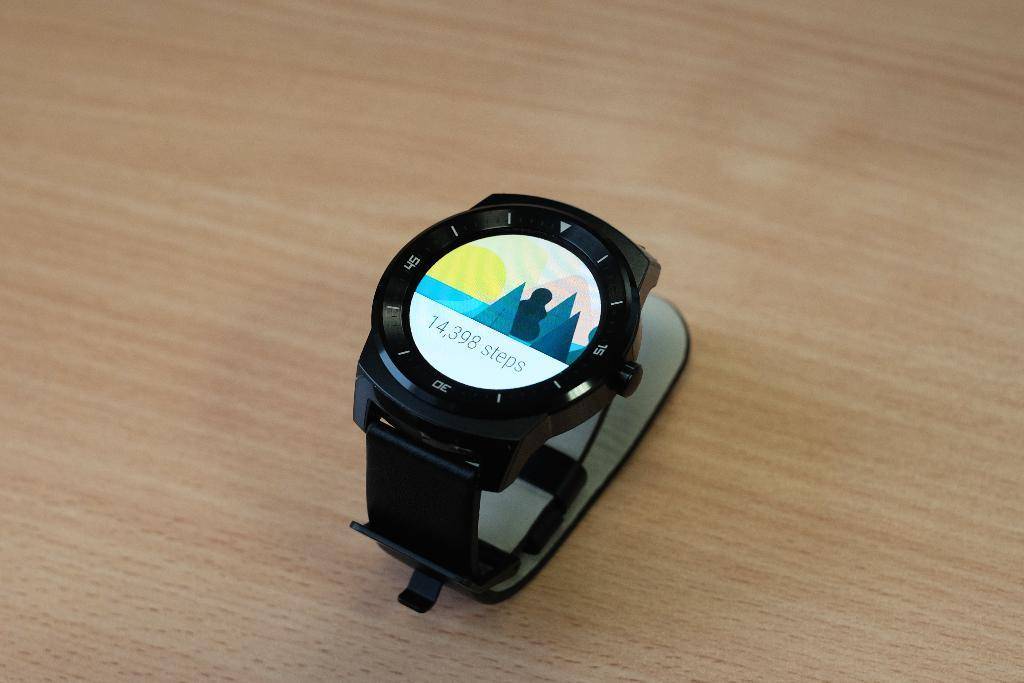<image>
Write a terse but informative summary of the picture. A fitness watch that has a measurement of 14,398 steps displayed on the screen. 